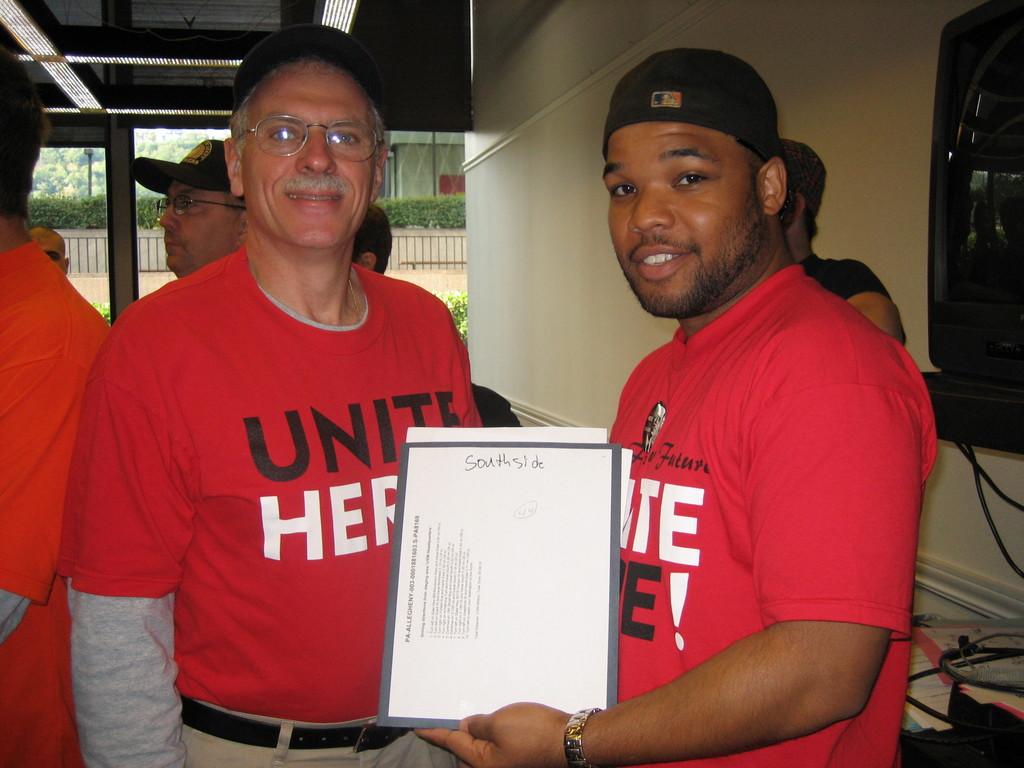What is the first word on the man on the left shirt?
Make the answer very short. Unite. Whats is written on the top of the paper?
Provide a short and direct response. Southside. 